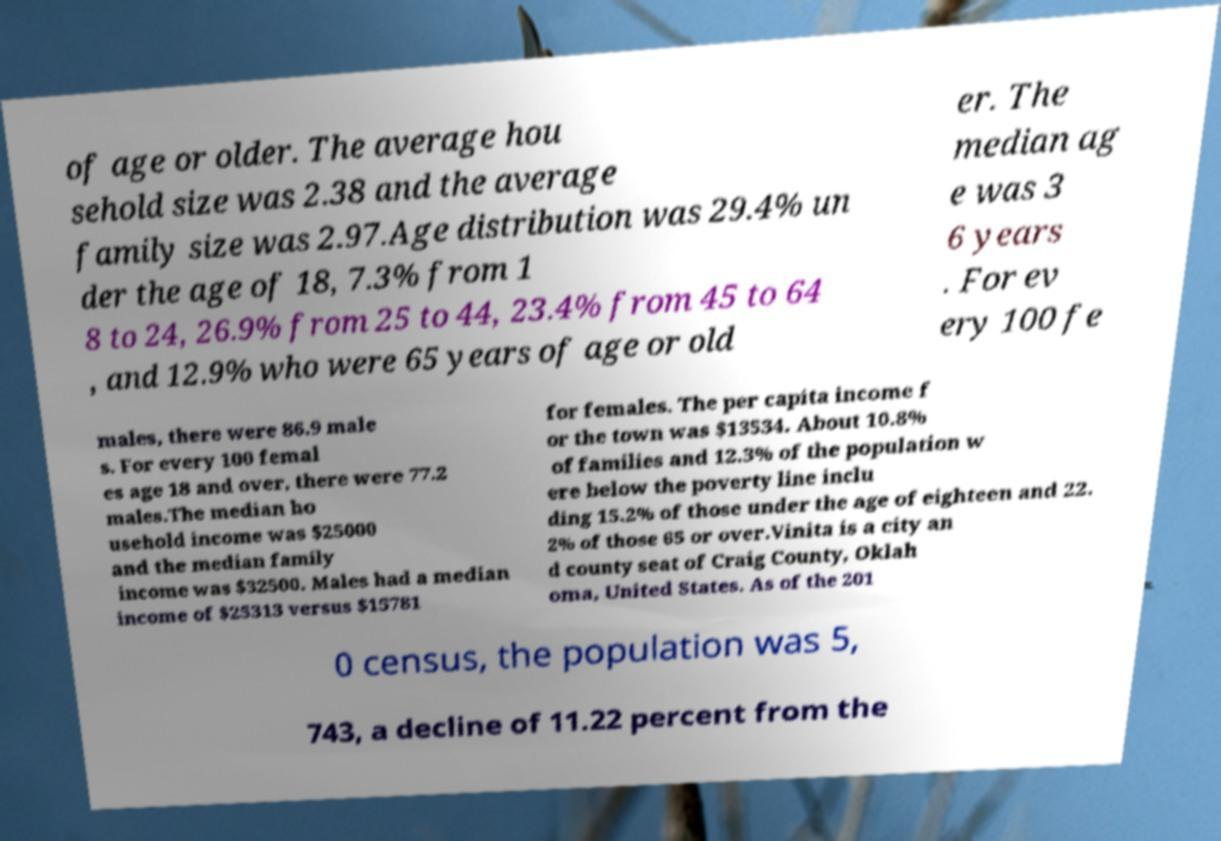Please read and relay the text visible in this image. What does it say? of age or older. The average hou sehold size was 2.38 and the average family size was 2.97.Age distribution was 29.4% un der the age of 18, 7.3% from 1 8 to 24, 26.9% from 25 to 44, 23.4% from 45 to 64 , and 12.9% who were 65 years of age or old er. The median ag e was 3 6 years . For ev ery 100 fe males, there were 86.9 male s. For every 100 femal es age 18 and over, there were 77.2 males.The median ho usehold income was $25000 and the median family income was $32500. Males had a median income of $25313 versus $15781 for females. The per capita income f or the town was $13534. About 10.8% of families and 12.3% of the population w ere below the poverty line inclu ding 15.2% of those under the age of eighteen and 22. 2% of those 65 or over.Vinita is a city an d county seat of Craig County, Oklah oma, United States. As of the 201 0 census, the population was 5, 743, a decline of 11.22 percent from the 